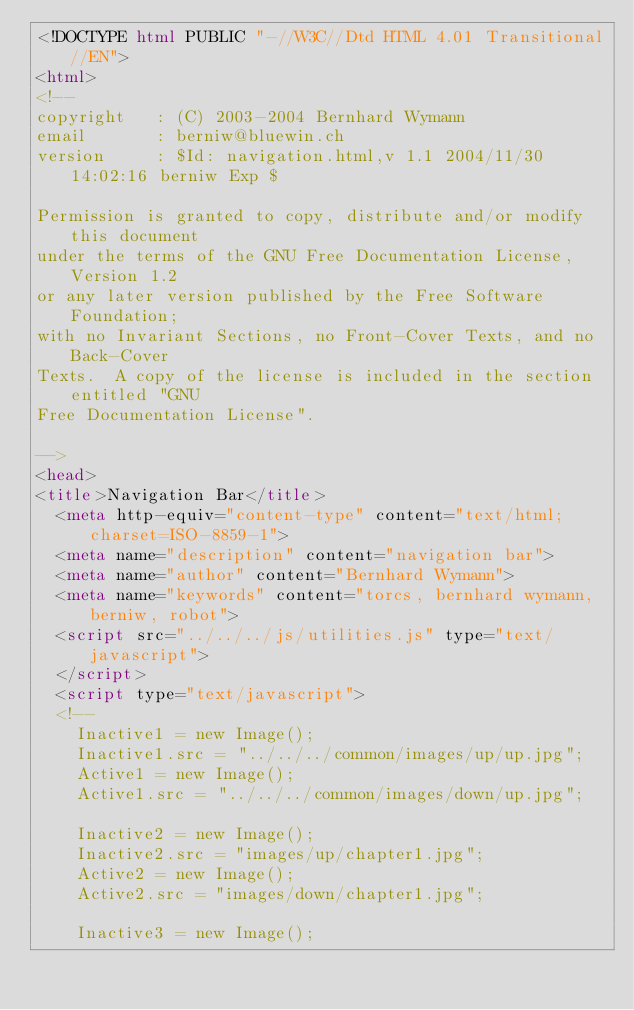Convert code to text. <code><loc_0><loc_0><loc_500><loc_500><_HTML_><!DOCTYPE html PUBLIC "-//W3C//Dtd HTML 4.01 Transitional//EN">
<html>
<!--
copyright   : (C) 2003-2004 Bernhard Wymann
email       : berniw@bluewin.ch
version     : $Id: navigation.html,v 1.1 2004/11/30 14:02:16 berniw Exp $

Permission is granted to copy, distribute and/or modify this document
under the terms of the GNU Free Documentation License, Version 1.2
or any later version published by the Free Software Foundation;
with no Invariant Sections, no Front-Cover Texts, and no Back-Cover
Texts.  A copy of the license is included in the section entitled "GNU
Free Documentation License".

-->
<head>
<title>Navigation Bar</title>
  <meta http-equiv="content-type" content="text/html; charset=ISO-8859-1">
  <meta name="description" content="navigation bar">
  <meta name="author" content="Bernhard Wymann">
  <meta name="keywords" content="torcs, bernhard wymann, berniw, robot">
  <script src="../../../js/utilities.js" type="text/javascript">
  </script>
  <script type="text/javascript">
  <!--
    Inactive1 = new Image();
    Inactive1.src = "../../../common/images/up/up.jpg";
    Active1 = new Image();
    Active1.src = "../../../common/images/down/up.jpg";

    Inactive2 = new Image();
    Inactive2.src = "images/up/chapter1.jpg";
    Active2 = new Image();
    Active2.src = "images/down/chapter1.jpg";

    Inactive3 = new Image();</code> 